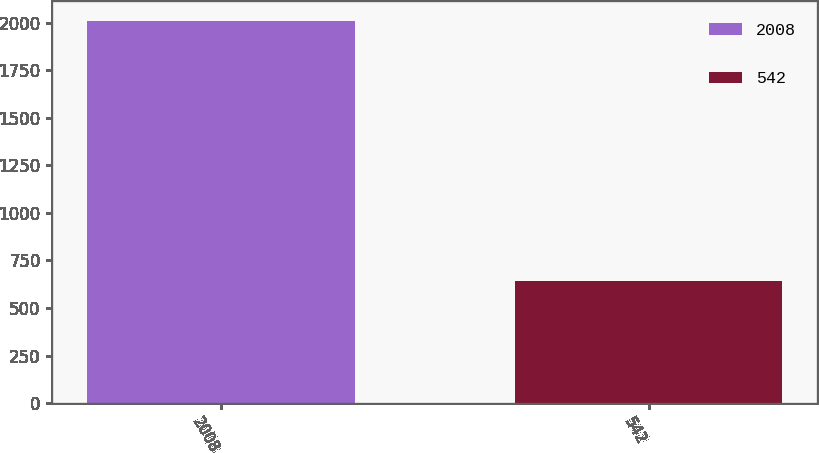<chart> <loc_0><loc_0><loc_500><loc_500><bar_chart><fcel>2008<fcel>542<nl><fcel>2011<fcel>642<nl></chart> 